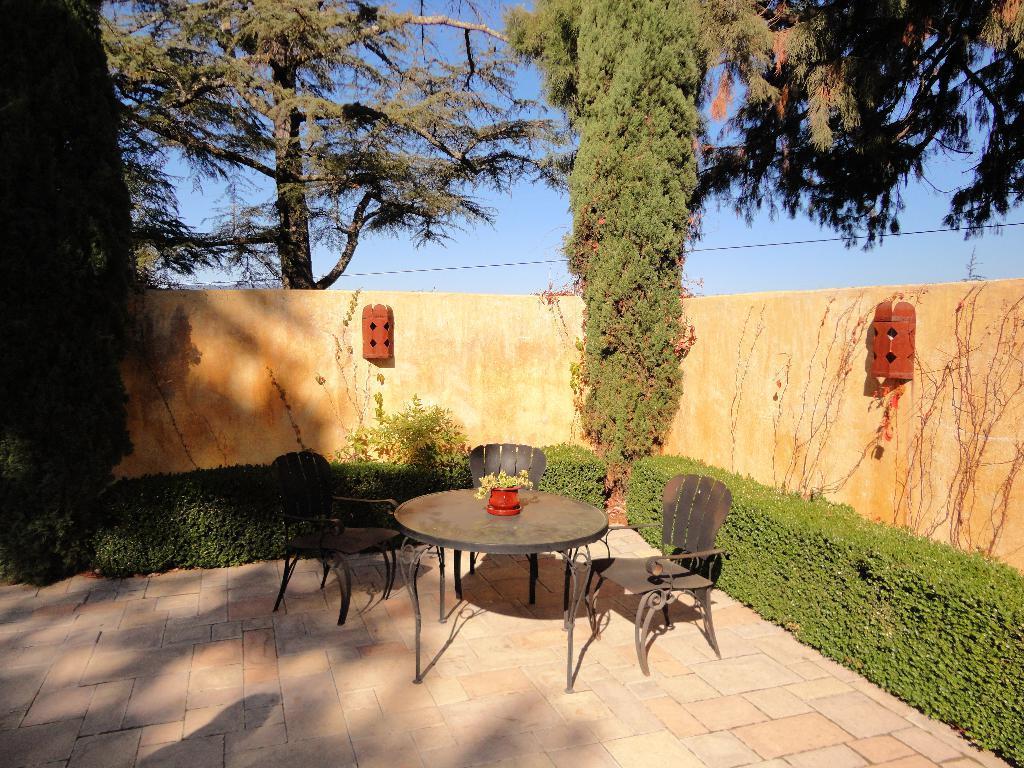Could you give a brief overview of what you see in this image? In the picture we can see a path with some chairs and table, on the table, we can see a flower pot which is red in color and in the background, we can see some plants, and wall and behind we can see a wall and some trees and sky. 